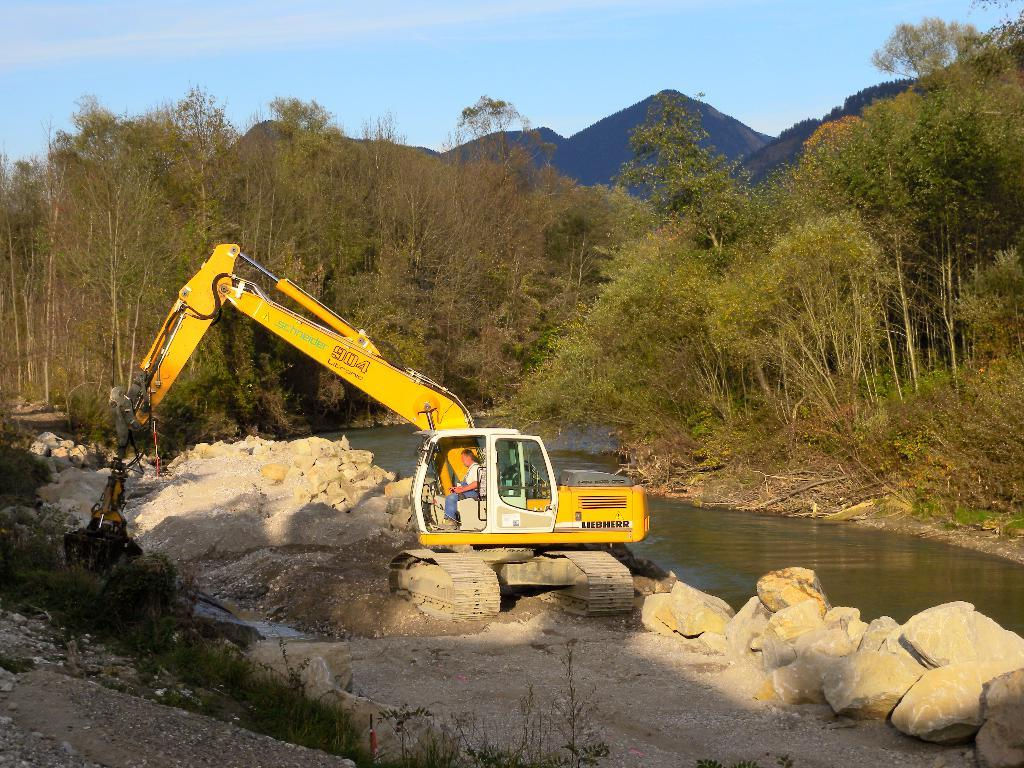What is the person in the image operating? The person is inside an excavator. What can be seen in the image besides the excavator? There is water, stones, grass, trees, and a mountain visible in the image. What is the natural environment like in the image? The image features grass, trees, and a mountain in the background, as well as water and stones. What is visible in the sky in the image? The sky is visible in the background of the image. How many boats can be seen in the image? There are no boats present in the image. What type of clothing is the person wearing to trade with others in the image? There is no indication of trading or clothing in the image; it features a person operating an excavator in a natural environment. 